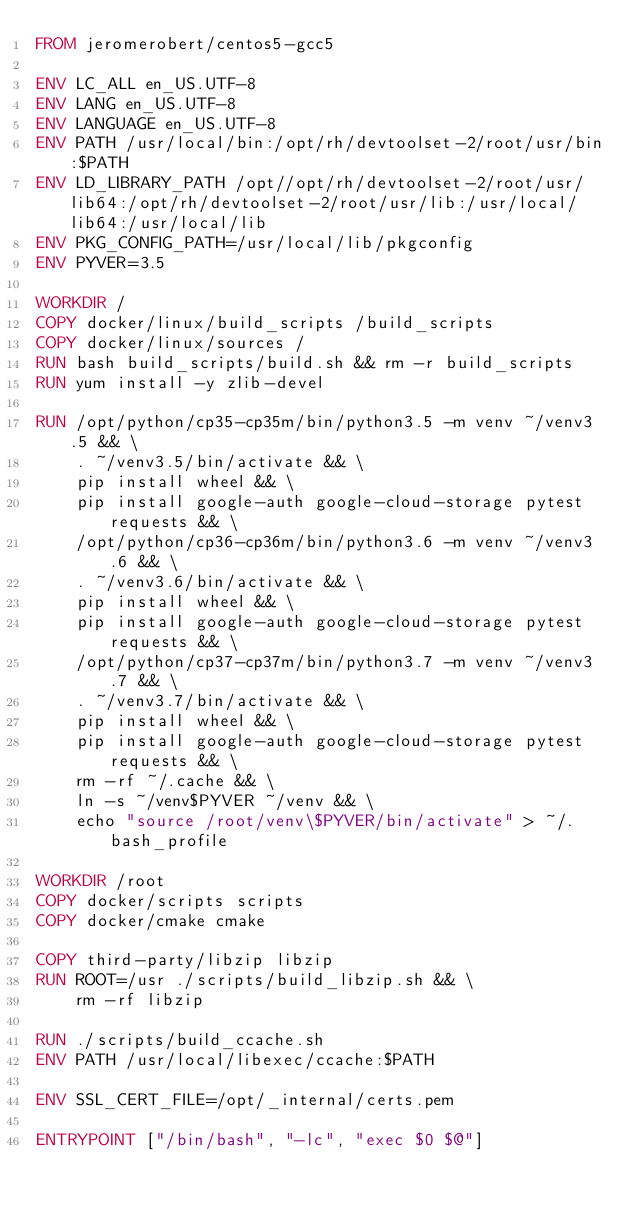Convert code to text. <code><loc_0><loc_0><loc_500><loc_500><_Dockerfile_>FROM jeromerobert/centos5-gcc5

ENV LC_ALL en_US.UTF-8
ENV LANG en_US.UTF-8
ENV LANGUAGE en_US.UTF-8
ENV PATH /usr/local/bin:/opt/rh/devtoolset-2/root/usr/bin:$PATH
ENV LD_LIBRARY_PATH /opt//opt/rh/devtoolset-2/root/usr/lib64:/opt/rh/devtoolset-2/root/usr/lib:/usr/local/lib64:/usr/local/lib
ENV PKG_CONFIG_PATH=/usr/local/lib/pkgconfig
ENV PYVER=3.5

WORKDIR /
COPY docker/linux/build_scripts /build_scripts
COPY docker/linux/sources /
RUN bash build_scripts/build.sh && rm -r build_scripts
RUN yum install -y zlib-devel

RUN /opt/python/cp35-cp35m/bin/python3.5 -m venv ~/venv3.5 && \
    . ~/venv3.5/bin/activate && \
    pip install wheel && \
    pip install google-auth google-cloud-storage pytest requests && \
    /opt/python/cp36-cp36m/bin/python3.6 -m venv ~/venv3.6 && \
    . ~/venv3.6/bin/activate && \
    pip install wheel && \
    pip install google-auth google-cloud-storage pytest requests && \
    /opt/python/cp37-cp37m/bin/python3.7 -m venv ~/venv3.7 && \
    . ~/venv3.7/bin/activate && \
    pip install wheel && \
    pip install google-auth google-cloud-storage pytest requests && \
    rm -rf ~/.cache && \
    ln -s ~/venv$PYVER ~/venv && \
    echo "source /root/venv\$PYVER/bin/activate" > ~/.bash_profile

WORKDIR /root
COPY docker/scripts scripts
COPY docker/cmake cmake

COPY third-party/libzip libzip
RUN ROOT=/usr ./scripts/build_libzip.sh && \
    rm -rf libzip

RUN ./scripts/build_ccache.sh
ENV PATH /usr/local/libexec/ccache:$PATH

ENV SSL_CERT_FILE=/opt/_internal/certs.pem

ENTRYPOINT ["/bin/bash", "-lc", "exec $0 $@"]
</code> 